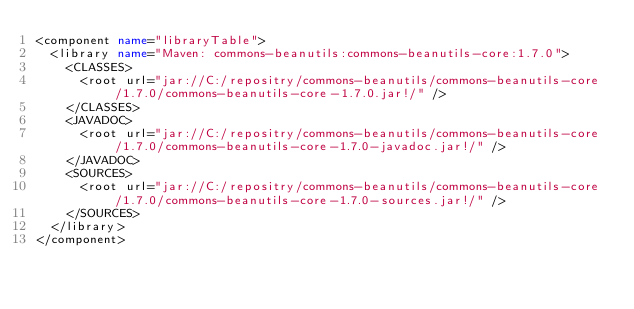Convert code to text. <code><loc_0><loc_0><loc_500><loc_500><_XML_><component name="libraryTable">
  <library name="Maven: commons-beanutils:commons-beanutils-core:1.7.0">
    <CLASSES>
      <root url="jar://C:/repositry/commons-beanutils/commons-beanutils-core/1.7.0/commons-beanutils-core-1.7.0.jar!/" />
    </CLASSES>
    <JAVADOC>
      <root url="jar://C:/repositry/commons-beanutils/commons-beanutils-core/1.7.0/commons-beanutils-core-1.7.0-javadoc.jar!/" />
    </JAVADOC>
    <SOURCES>
      <root url="jar://C:/repositry/commons-beanutils/commons-beanutils-core/1.7.0/commons-beanutils-core-1.7.0-sources.jar!/" />
    </SOURCES>
  </library>
</component></code> 